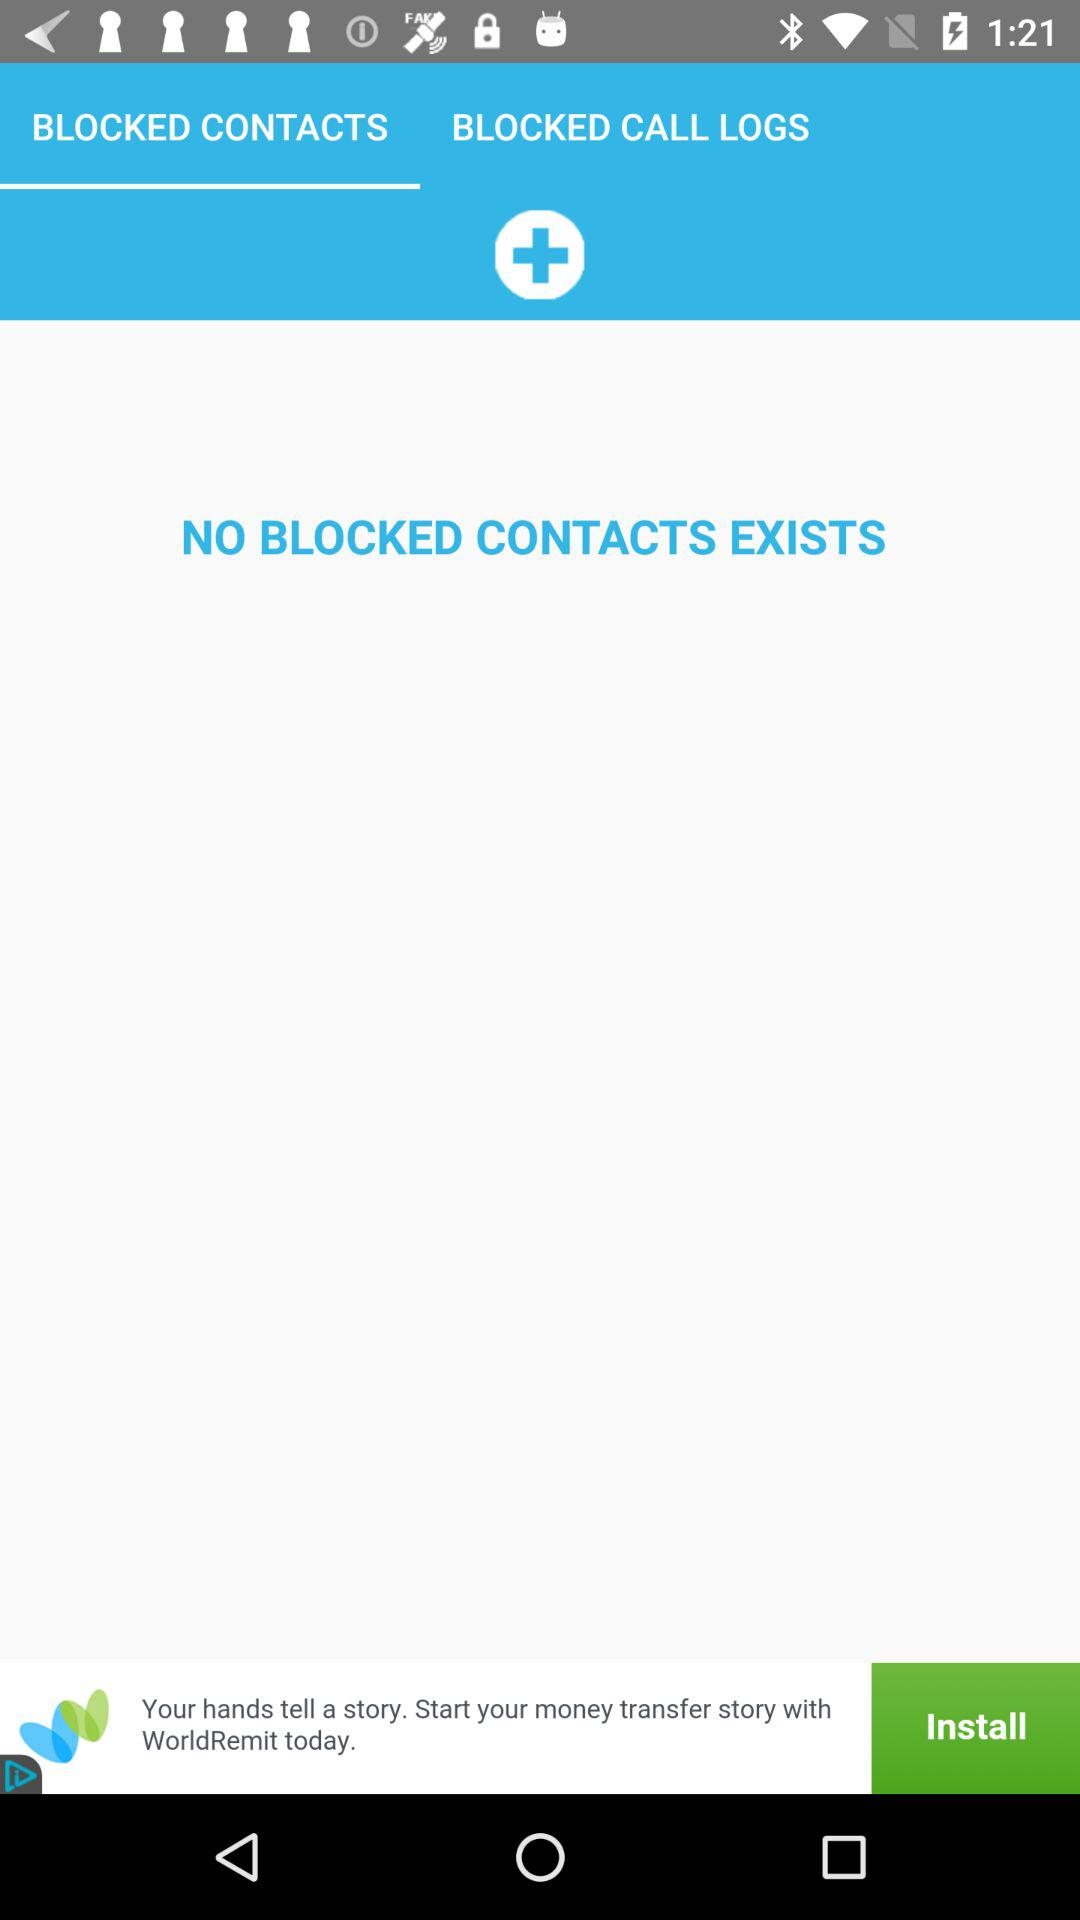How many blocked contacts are there?
Answer the question using a single word or phrase. 0 